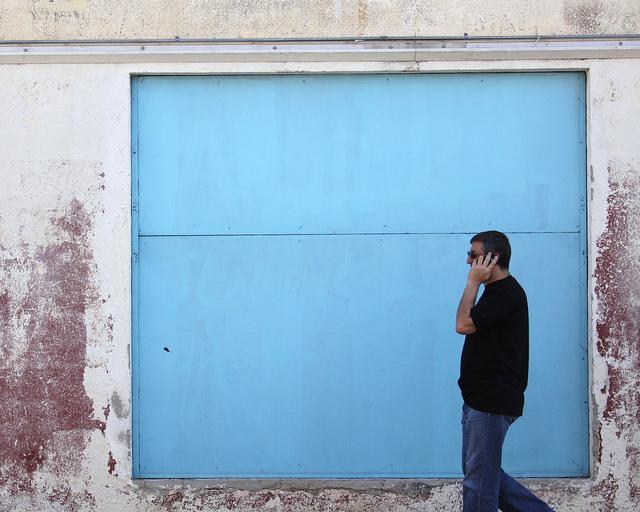Is the man wearing glasses?
Concise answer only. Yes. What color is the door?
Answer briefly. Blue. What is the man holding?
Concise answer only. Cell phone. 